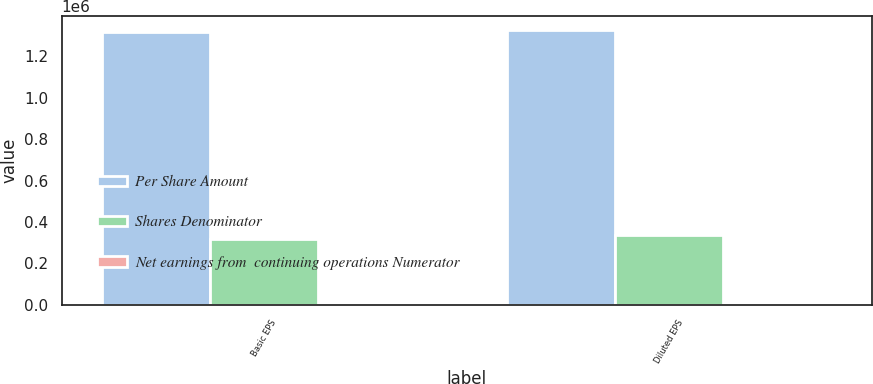Convert chart. <chart><loc_0><loc_0><loc_500><loc_500><stacked_bar_chart><ecel><fcel>Basic EPS<fcel>Diluted EPS<nl><fcel>Per Share Amount<fcel>1.31763e+06<fcel>1.328e+06<nl><fcel>Shares Denominator<fcel>319361<fcel>335863<nl><fcel>Net earnings from  continuing operations Numerator<fcel>4.13<fcel>3.95<nl></chart> 